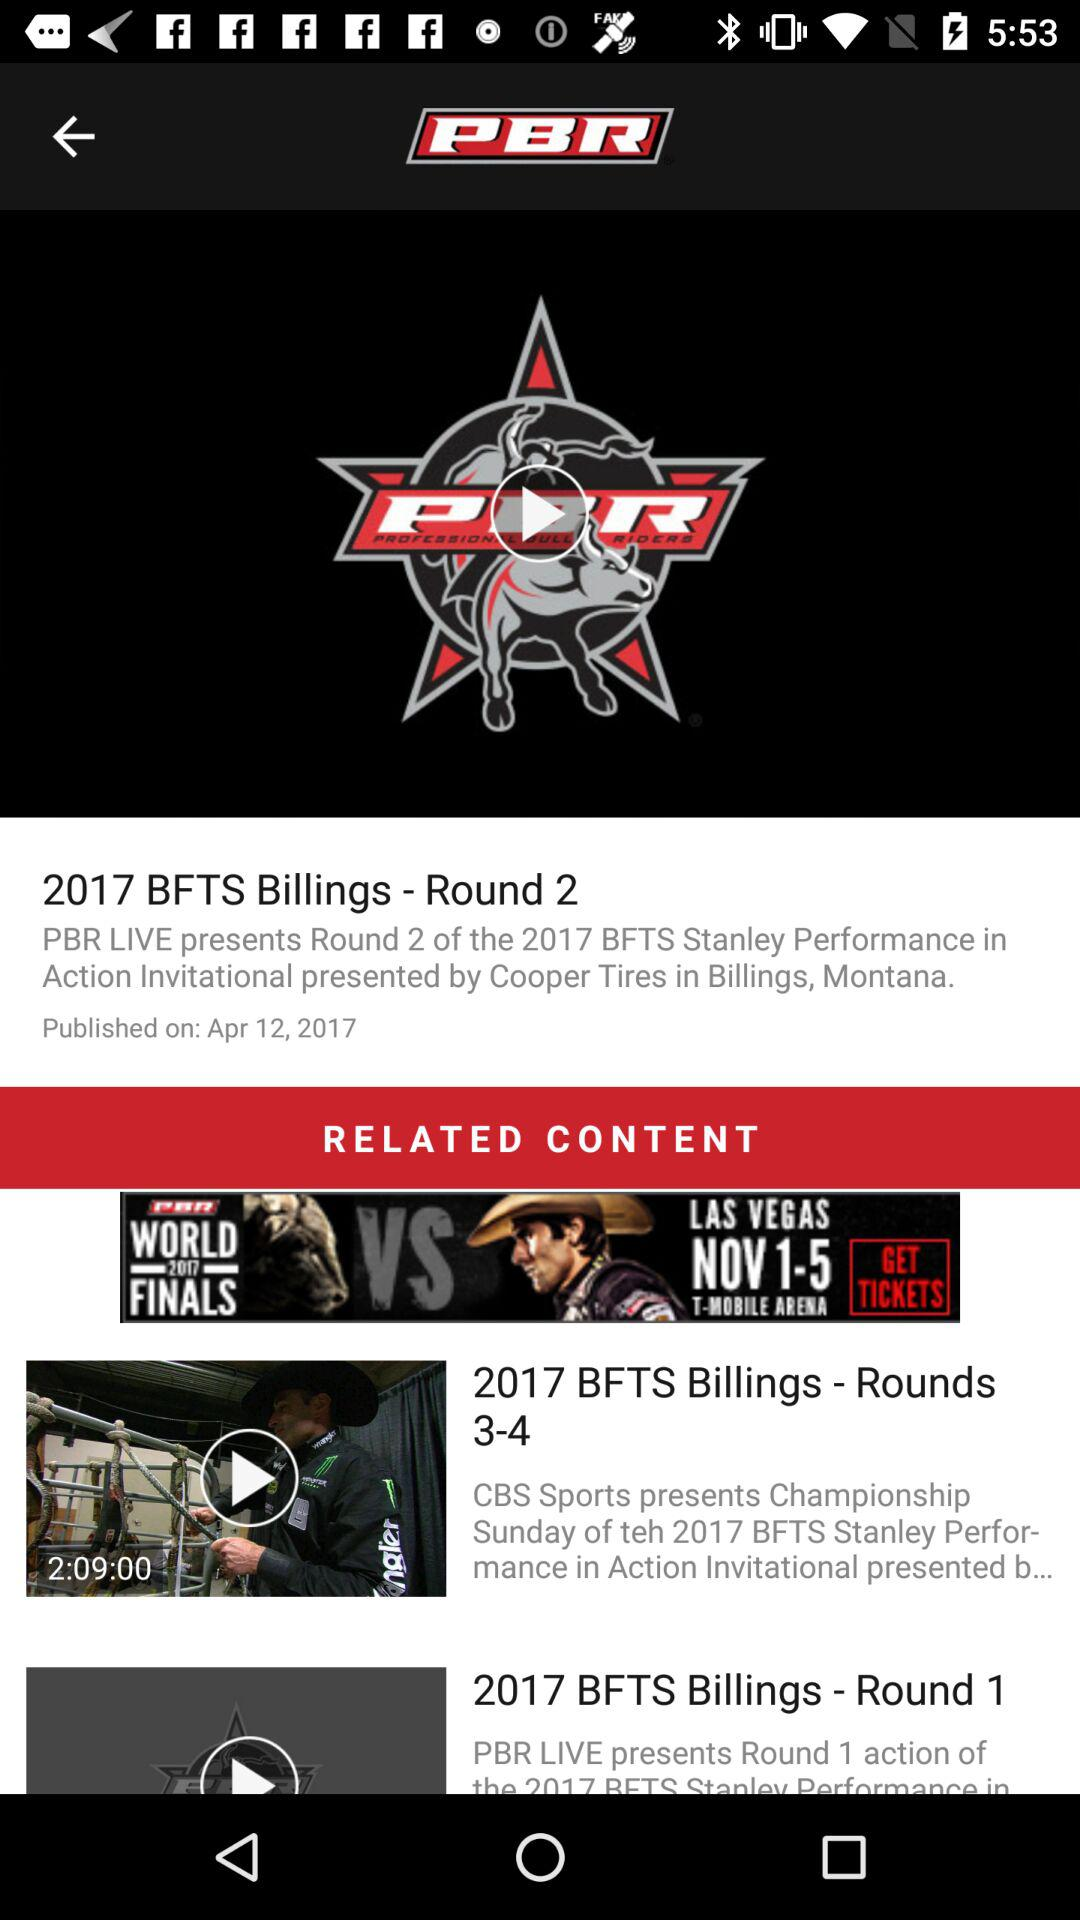What is the time duration of the "2017 BFTS Billing - Round 3-4"? The time duration is 2 hours and 9 minutes. 